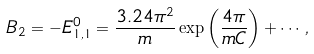Convert formula to latex. <formula><loc_0><loc_0><loc_500><loc_500>B _ { 2 } = - E _ { 1 , 1 } ^ { 0 } = \frac { 3 . 2 4 \pi ^ { 2 } } { m } \exp \left ( \frac { 4 \pi } { m C } \right ) + \cdots ,</formula> 